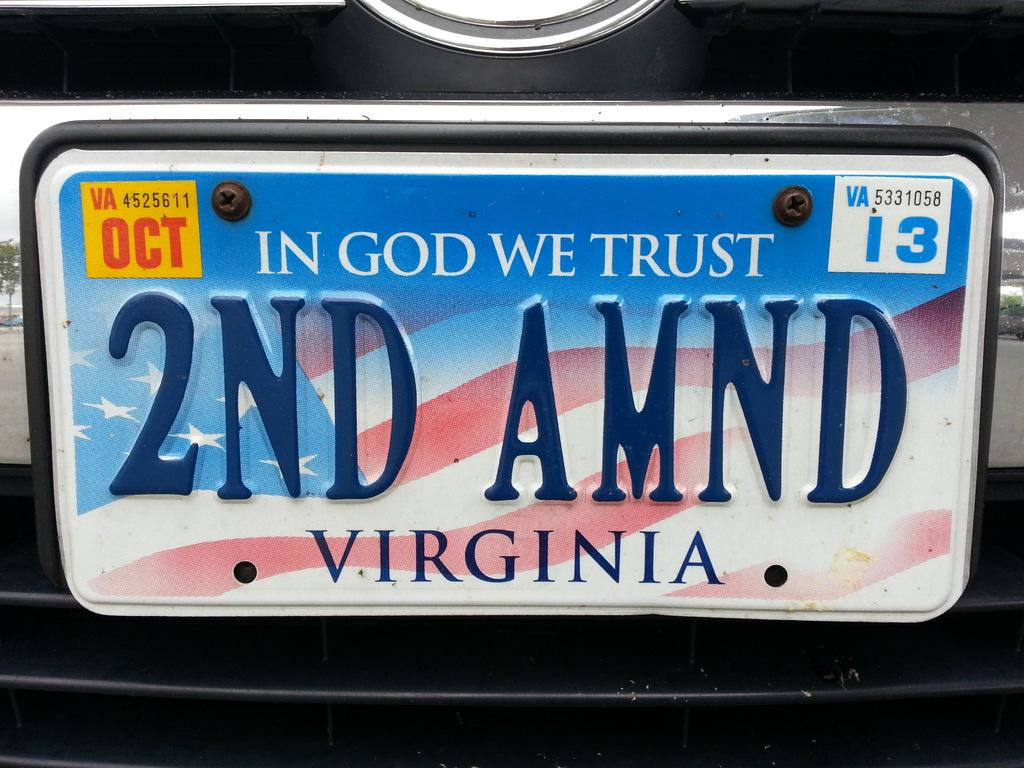<image>
Summarize the visual content of the image. Colorful license plate which says "In God We Trust". 